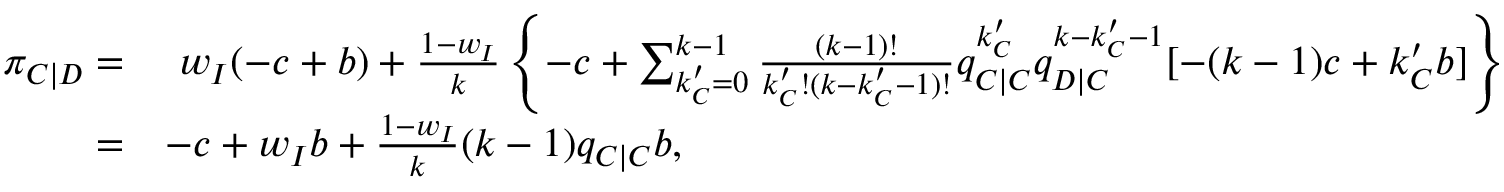Convert formula to latex. <formula><loc_0><loc_0><loc_500><loc_500>\begin{array} { r l } { \pi _ { C | D } = } & { w _ { I } ( - c + b ) + \frac { 1 - w _ { I } } { k } \left \{ - c + \sum _ { k _ { C } ^ { \prime } = 0 } ^ { k - 1 } { \frac { ( k - 1 ) ! } { k _ { C } ^ { \prime } ! ( k - k _ { C } ^ { \prime } - 1 ) ! } q _ { C | C } ^ { k _ { C } ^ { \prime } } q _ { D | C } ^ { k - k _ { C } ^ { \prime } - 1 } [ - ( k - 1 ) c + k _ { C } ^ { \prime } b ] } \right \} } \\ { = } & { - c + w _ { I } b + \frac { 1 - w _ { I } } { k } ( k - 1 ) q _ { C | C } b , } \end{array}</formula> 